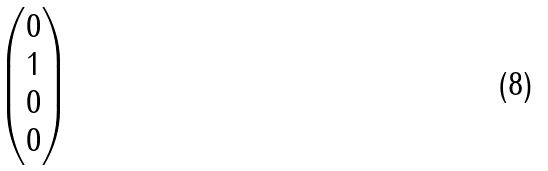Convert formula to latex. <formula><loc_0><loc_0><loc_500><loc_500>\begin{pmatrix} 0 \\ 1 \\ 0 \\ 0 \\ \end{pmatrix}</formula> 